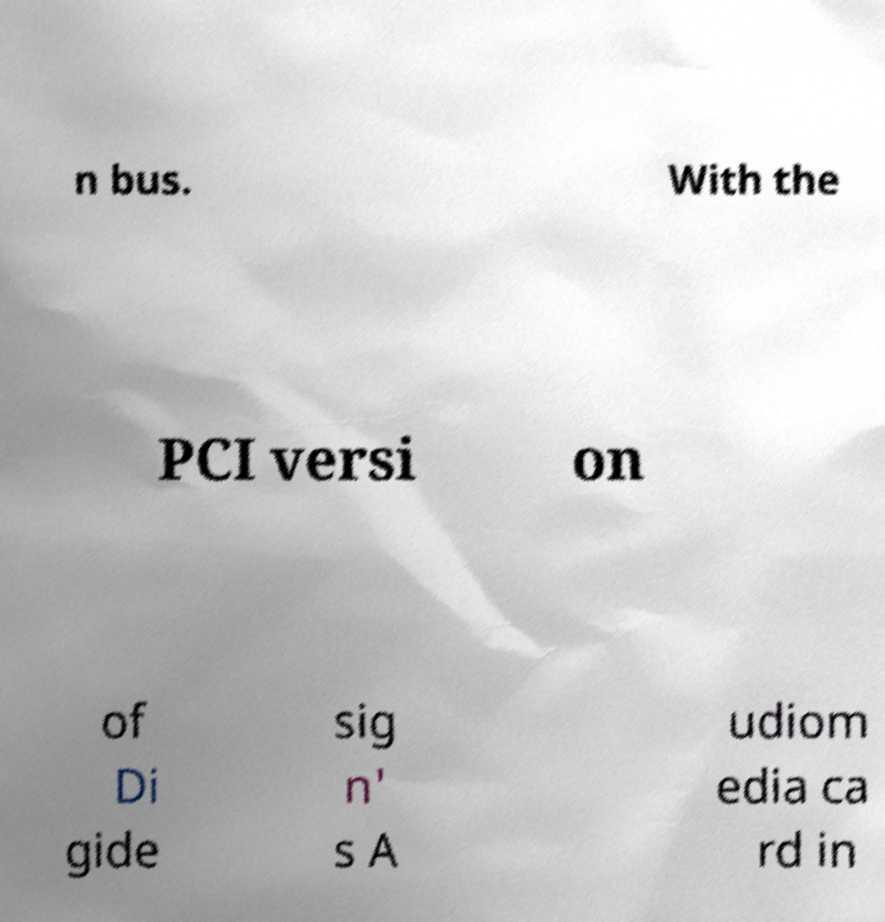What messages or text are displayed in this image? I need them in a readable, typed format. n bus. With the PCI versi on of Di gide sig n' s A udiom edia ca rd in 